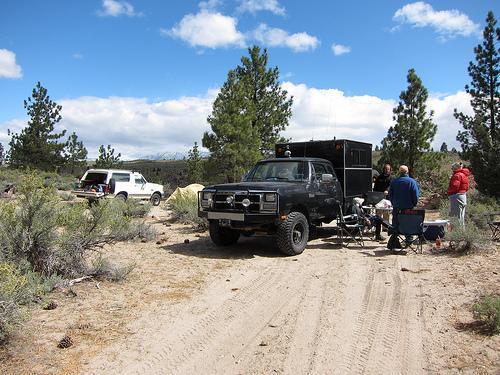How many tall trees can be counted?
Give a very brief answer. 4. How many people are shown?
Give a very brief answer. 3. How many vehicles are visible?
Give a very brief answer. 2. How many people are wearing a red coat?
Give a very brief answer. 1. How many animals are pictured?
Give a very brief answer. 0. 